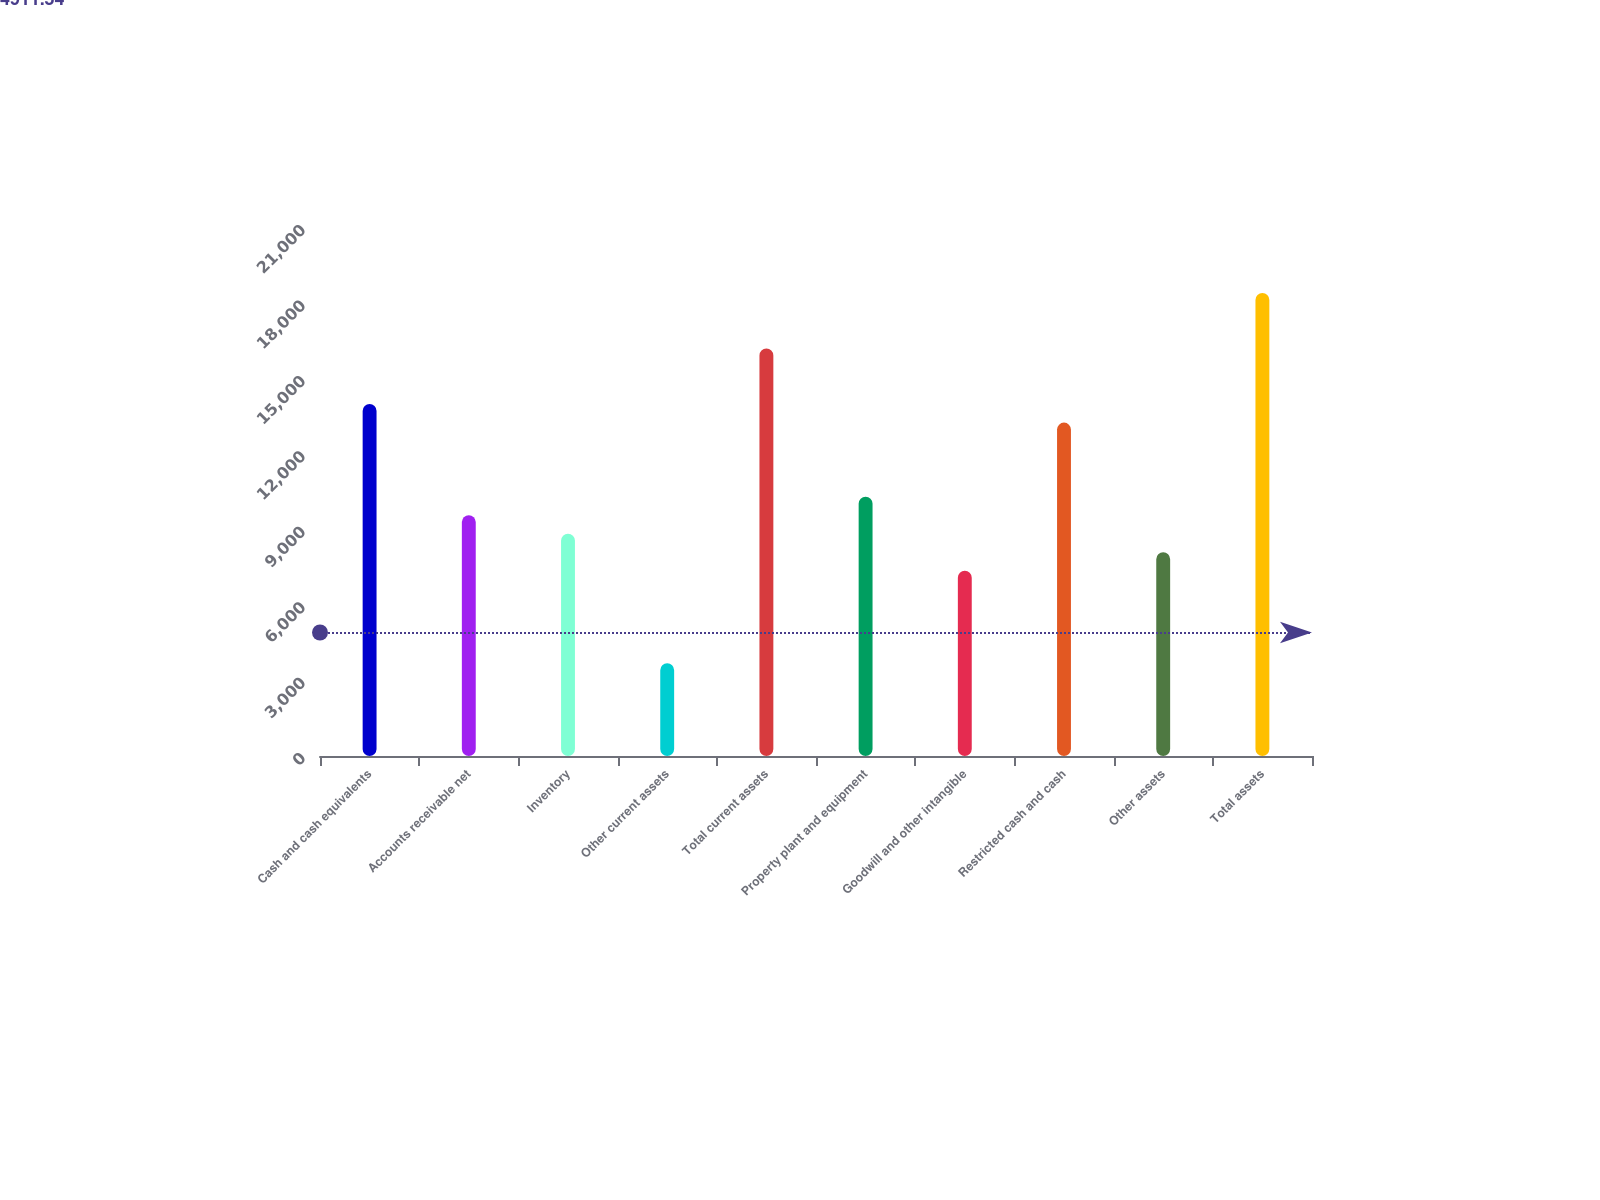Convert chart. <chart><loc_0><loc_0><loc_500><loc_500><bar_chart><fcel>Cash and cash equivalents<fcel>Accounts receivable net<fcel>Inventory<fcel>Other current assets<fcel>Total current assets<fcel>Property plant and equipment<fcel>Goodwill and other intangible<fcel>Restricted cash and cash<fcel>Other assets<fcel>Total assets<nl><fcel>13996.6<fcel>9578.2<fcel>8841.8<fcel>3687<fcel>16205.8<fcel>10314.6<fcel>7369<fcel>13260.2<fcel>8105.4<fcel>18415<nl></chart> 